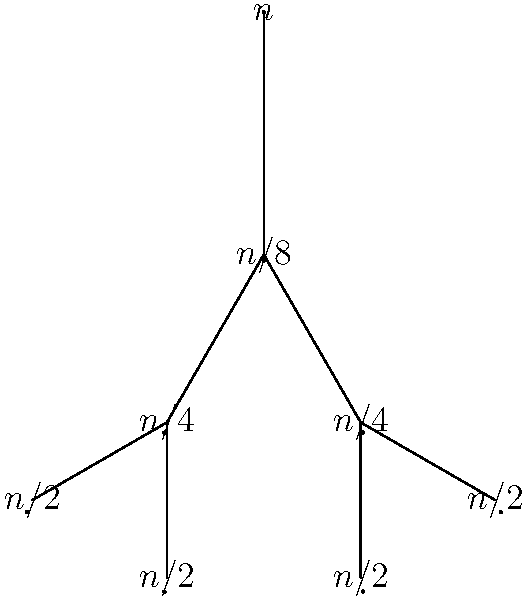Consider the following recursive algorithm:

```
T(n) = {
    1,               if n <= 1
    2T(n/2) + n,     if n > 1
}
```

Using the recursion tree method, determine the time complexity of this algorithm. Write your answer using Big O notation. Let's analyze this recursive algorithm step-by-step using the recursion tree method:

1) The root of the tree represents the original problem of size $n$.

2) At each level, we split the problem into two subproblems of size $n/2$.

3) The work done at each node (excluding recursive calls) is proportional to the problem size at that node.

4) Let's expand the tree:
   - Root: work done = $n$
   - Level 1: Two nodes, each with work = $n/2$. Total work at this level = $2(n/2) = n$
   - Level 2: Four nodes, each with work = $n/4$. Total work at this level = $4(n/4) = n$
   - This continues until we reach the base case.

5) The number of levels in the tree:
   - At each level, $n$ is divided by 2
   - We stop when $n/(2^k) = 1$, where $k$ is the number of levels
   - Solving this: $n = 2^k$, or $k = \log_2 n$

6) The total work done:
   - Each level contributes $n$ amount of work
   - There are $\log_2 n$ levels
   - Total work = $n \cdot \log_2 n$

7) The base cases at the leaves contribute $O(n)$ additional work, but this is dominated by the $n \log n$ term.

Therefore, the time complexity of this algorithm is $O(n \log n)$.
Answer: $O(n \log n)$ 